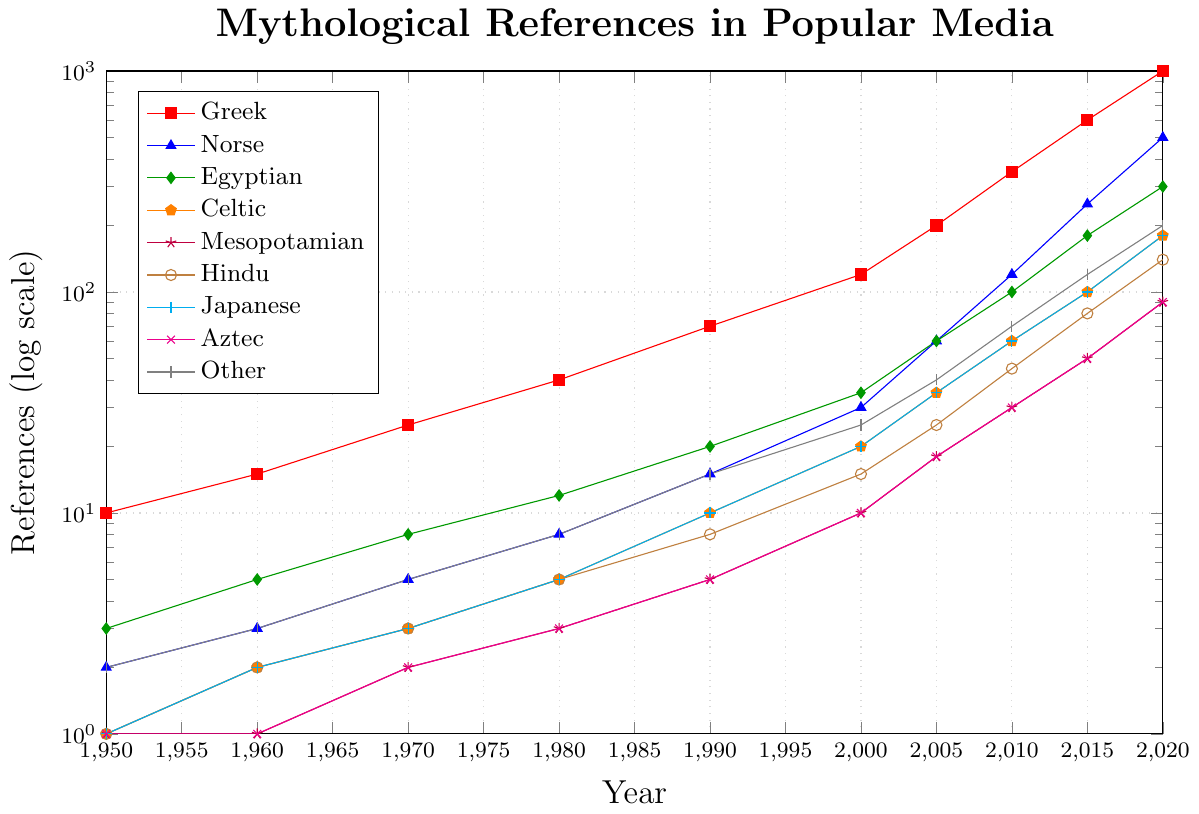Which pantheon has the highest number of references in 2020? By visually inspecting the logscale chart, observe the topmost line in 2020. The Greek pantheon, represented by the topmost red line, has the highest value.
Answer: Greek How many total mythological references were there in 1980 for Greek and Norse combined? Locate the values for Greek and Norse in 1980. Greek is at 40 and Norse is at 8. Sum them up: 40 + 8 = 48.
Answer: 48 Which pantheon shows the most significant increase in references between 2010 and 2015? Observe the gradients of the lines between 2010 and 2015. The Norse pantheon (blue line) appears to have the steepest increase, going from 120 to 250 references.
Answer: Norse What is the average number of references for the Celtic pantheon between 1950 and 2020? Add up the values for the Celtic pantheon and divide by the number of data points: (1+2+3+5+10+20+35+60+100+180)/10 = 41.6.
Answer: 41.6 Which pantheon remains the most steady with relatively minor increases over time? By visually examining the chart, the Aztec pantheon (magenta line) shows relatively steady, less steep increases compared to others.
Answer: Aztec What was the difference in mythological references between Egyptian and Hindu pantheons in 2000? From the chart, Egyptian pantheon has 35 references and Hindu has 15. Calculate the difference: 35 - 15 = 20.
Answer: 20 Which pantheon experienced the earliest noticeable increase above 50 references? Look for the earliest point where a line crosses 50 references. Norse (blue line) crosses 50 references in 2005.
Answer: Norse What are the total mythological references for all pantheons combined in 2020? Sum up the values for each pantheon in 2020: 1000 (Greek) + 500 (Norse) + 300 (Egyptian) + 180 (Celtic) + 90 (Mesopotamian) + 140 (Hindu) + 180 (Japanese) + 90 (Aztec) + 200 (Other) = 2680.
Answer: 2680 